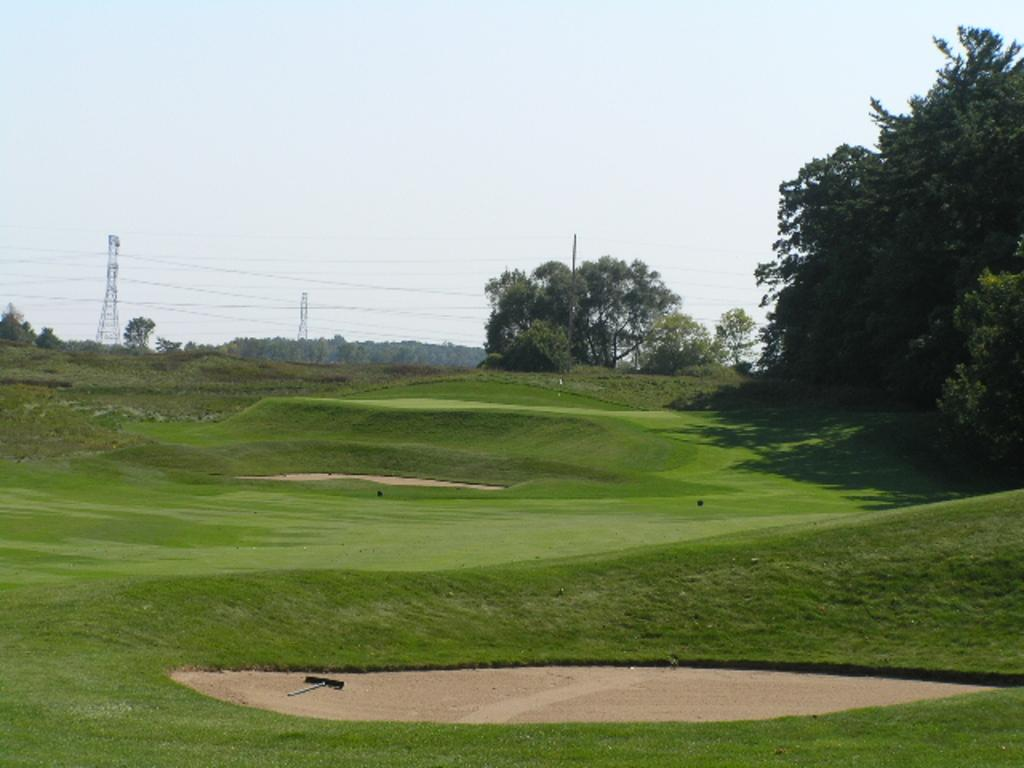What type of vegetation can be seen in the image? There are trees in the image. What type of area is depicted in the image? There is a garden in the image. What else can be seen in the image besides the garden? Wires and towers are present in the image. What is the color of the sky in the image? The sky is white and blue in color. What type of animal can be seen in the garden in the image? There are no animals present in the image. What type of oven is visible in the image? There is no oven present in the image. 